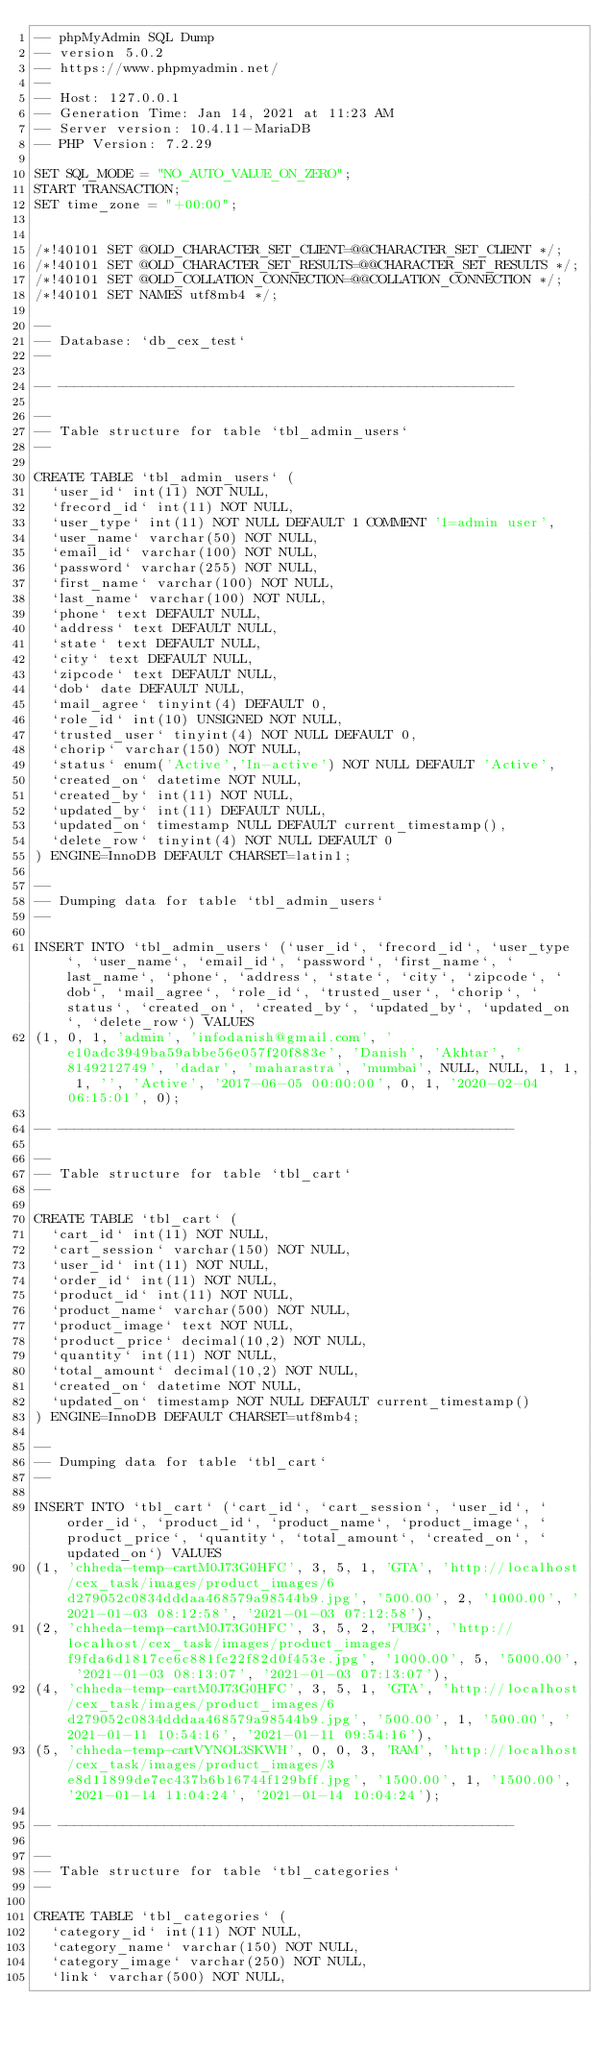Convert code to text. <code><loc_0><loc_0><loc_500><loc_500><_SQL_>-- phpMyAdmin SQL Dump
-- version 5.0.2
-- https://www.phpmyadmin.net/
--
-- Host: 127.0.0.1
-- Generation Time: Jan 14, 2021 at 11:23 AM
-- Server version: 10.4.11-MariaDB
-- PHP Version: 7.2.29

SET SQL_MODE = "NO_AUTO_VALUE_ON_ZERO";
START TRANSACTION;
SET time_zone = "+00:00";


/*!40101 SET @OLD_CHARACTER_SET_CLIENT=@@CHARACTER_SET_CLIENT */;
/*!40101 SET @OLD_CHARACTER_SET_RESULTS=@@CHARACTER_SET_RESULTS */;
/*!40101 SET @OLD_COLLATION_CONNECTION=@@COLLATION_CONNECTION */;
/*!40101 SET NAMES utf8mb4 */;

--
-- Database: `db_cex_test`
--

-- --------------------------------------------------------

--
-- Table structure for table `tbl_admin_users`
--

CREATE TABLE `tbl_admin_users` (
  `user_id` int(11) NOT NULL,
  `frecord_id` int(11) NOT NULL,
  `user_type` int(11) NOT NULL DEFAULT 1 COMMENT '1=admin user',
  `user_name` varchar(50) NOT NULL,
  `email_id` varchar(100) NOT NULL,
  `password` varchar(255) NOT NULL,
  `first_name` varchar(100) NOT NULL,
  `last_name` varchar(100) NOT NULL,
  `phone` text DEFAULT NULL,
  `address` text DEFAULT NULL,
  `state` text DEFAULT NULL,
  `city` text DEFAULT NULL,
  `zipcode` text DEFAULT NULL,
  `dob` date DEFAULT NULL,
  `mail_agree` tinyint(4) DEFAULT 0,
  `role_id` int(10) UNSIGNED NOT NULL,
  `trusted_user` tinyint(4) NOT NULL DEFAULT 0,
  `chorip` varchar(150) NOT NULL,
  `status` enum('Active','In-active') NOT NULL DEFAULT 'Active',
  `created_on` datetime NOT NULL,
  `created_by` int(11) NOT NULL,
  `updated_by` int(11) DEFAULT NULL,
  `updated_on` timestamp NULL DEFAULT current_timestamp(),
  `delete_row` tinyint(4) NOT NULL DEFAULT 0
) ENGINE=InnoDB DEFAULT CHARSET=latin1;

--
-- Dumping data for table `tbl_admin_users`
--

INSERT INTO `tbl_admin_users` (`user_id`, `frecord_id`, `user_type`, `user_name`, `email_id`, `password`, `first_name`, `last_name`, `phone`, `address`, `state`, `city`, `zipcode`, `dob`, `mail_agree`, `role_id`, `trusted_user`, `chorip`, `status`, `created_on`, `created_by`, `updated_by`, `updated_on`, `delete_row`) VALUES
(1, 0, 1, 'admin', 'infodanish@gmail.com', 'e10adc3949ba59abbe56e057f20f883e', 'Danish', 'Akhtar', '8149212749', 'dadar', 'maharastra', 'mumbai', NULL, NULL, 1, 1, 1, '', 'Active', '2017-06-05 00:00:00', 0, 1, '2020-02-04 06:15:01', 0);

-- --------------------------------------------------------

--
-- Table structure for table `tbl_cart`
--

CREATE TABLE `tbl_cart` (
  `cart_id` int(11) NOT NULL,
  `cart_session` varchar(150) NOT NULL,
  `user_id` int(11) NOT NULL,
  `order_id` int(11) NOT NULL,
  `product_id` int(11) NOT NULL,
  `product_name` varchar(500) NOT NULL,
  `product_image` text NOT NULL,
  `product_price` decimal(10,2) NOT NULL,
  `quantity` int(11) NOT NULL,
  `total_amount` decimal(10,2) NOT NULL,
  `created_on` datetime NOT NULL,
  `updated_on` timestamp NOT NULL DEFAULT current_timestamp()
) ENGINE=InnoDB DEFAULT CHARSET=utf8mb4;

--
-- Dumping data for table `tbl_cart`
--

INSERT INTO `tbl_cart` (`cart_id`, `cart_session`, `user_id`, `order_id`, `product_id`, `product_name`, `product_image`, `product_price`, `quantity`, `total_amount`, `created_on`, `updated_on`) VALUES
(1, 'chheda-temp-cartM0J73G0HFC', 3, 5, 1, 'GTA', 'http://localhost/cex_task/images/product_images/6d279052c0834dddaa468579a98544b9.jpg', '500.00', 2, '1000.00', '2021-01-03 08:12:58', '2021-01-03 07:12:58'),
(2, 'chheda-temp-cartM0J73G0HFC', 3, 5, 2, 'PUBG', 'http://localhost/cex_task/images/product_images/f9fda6d1817ce6c881fe22f82d0f453e.jpg', '1000.00', 5, '5000.00', '2021-01-03 08:13:07', '2021-01-03 07:13:07'),
(4, 'chheda-temp-cartM0J73G0HFC', 3, 5, 1, 'GTA', 'http://localhost/cex_task/images/product_images/6d279052c0834dddaa468579a98544b9.jpg', '500.00', 1, '500.00', '2021-01-11 10:54:16', '2021-01-11 09:54:16'),
(5, 'chheda-temp-cartVYNOL3SKWH', 0, 0, 3, 'RAM', 'http://localhost/cex_task/images/product_images/3e8d11899de7ec437b6b16744f129bff.jpg', '1500.00', 1, '1500.00', '2021-01-14 11:04:24', '2021-01-14 10:04:24');

-- --------------------------------------------------------

--
-- Table structure for table `tbl_categories`
--

CREATE TABLE `tbl_categories` (
  `category_id` int(11) NOT NULL,
  `category_name` varchar(150) NOT NULL,
  `category_image` varchar(250) NOT NULL,
  `link` varchar(500) NOT NULL,</code> 